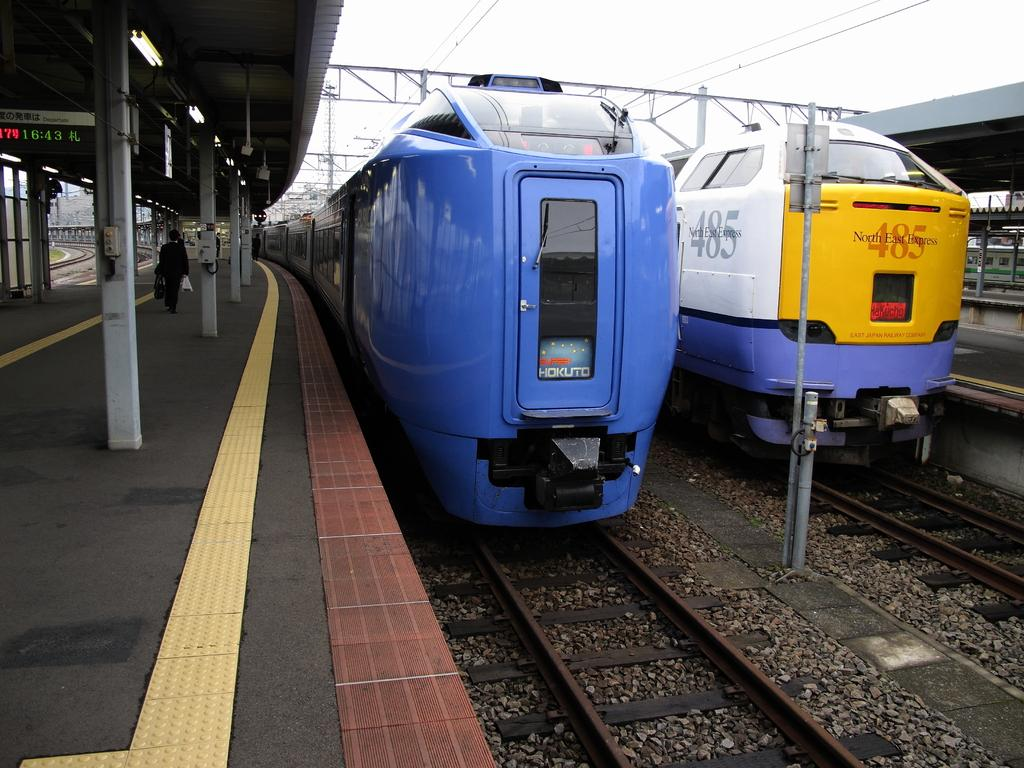<image>
Write a terse but informative summary of the picture. the number 485 that is on the front of a train 